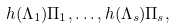Convert formula to latex. <formula><loc_0><loc_0><loc_500><loc_500>h ( \Lambda _ { 1 } ) \Pi _ { 1 } , \dots , h ( \Lambda _ { s } ) \Pi _ { s } ,</formula> 